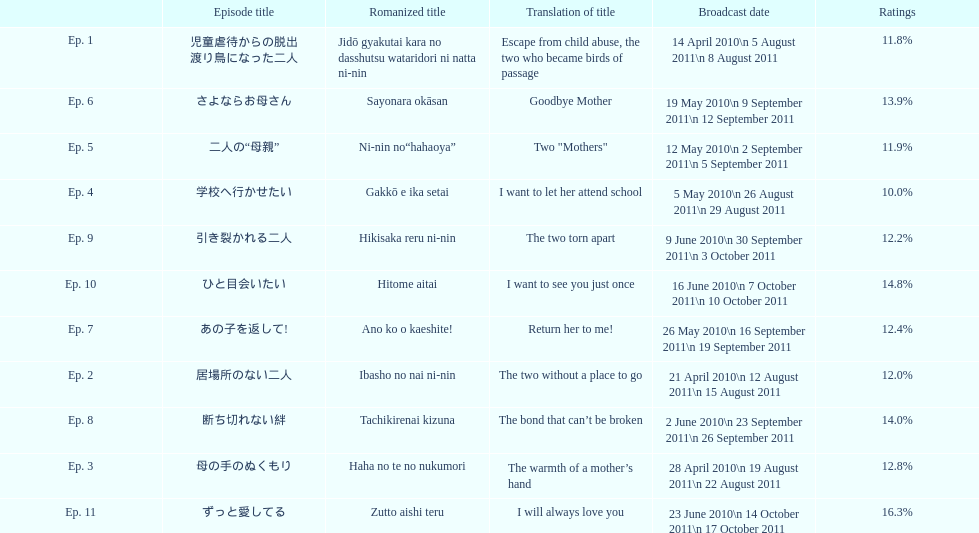What episode number was the only episode to have over 16% of ratings? 11. 